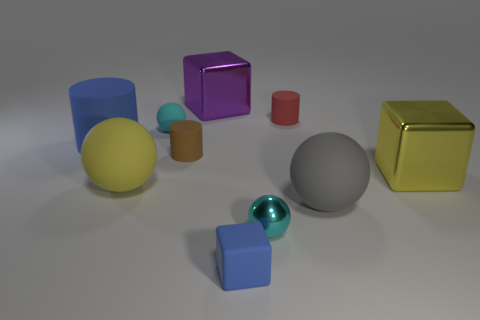Subtract all blocks. How many objects are left? 7 Add 4 big purple things. How many big purple things are left? 5 Add 8 tiny brown objects. How many tiny brown objects exist? 9 Subtract 1 purple blocks. How many objects are left? 9 Subtract all big rubber cylinders. Subtract all small rubber balls. How many objects are left? 8 